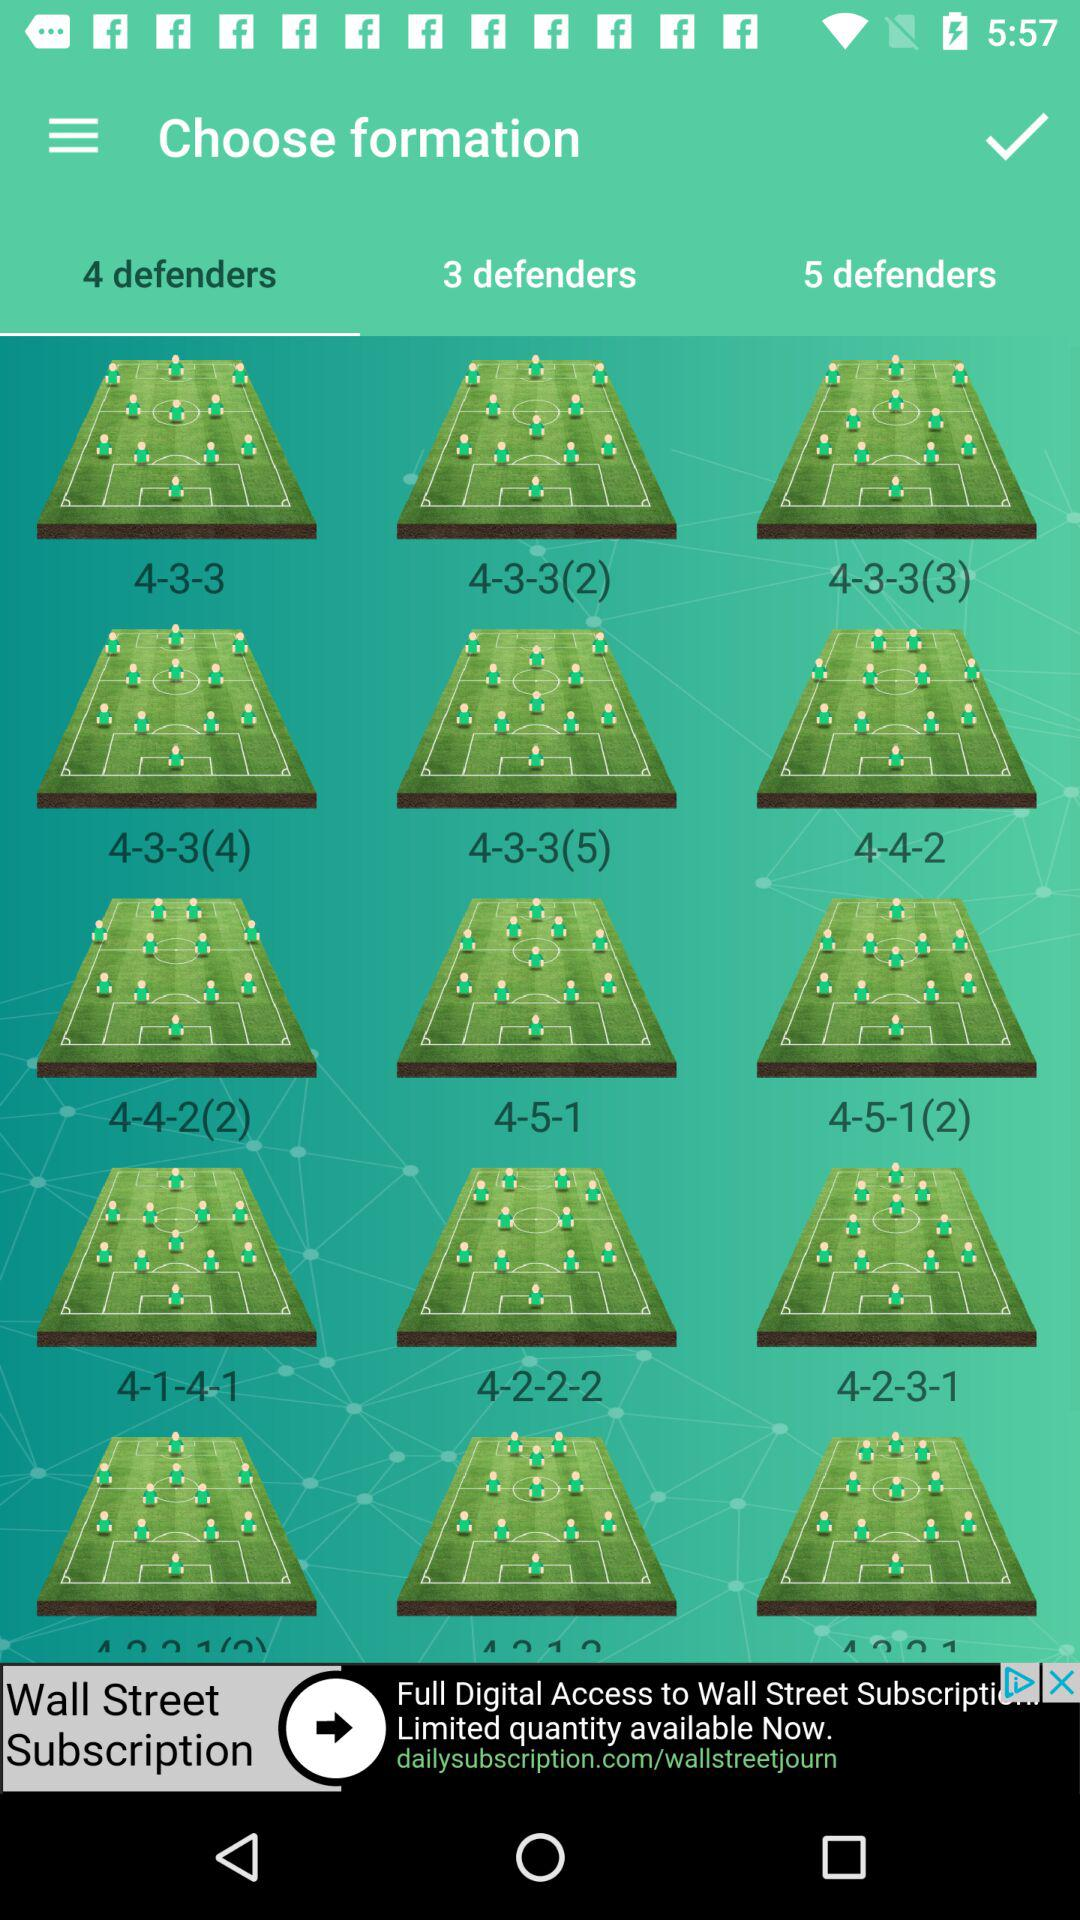Which "3 defenders" formation is selected?
When the provided information is insufficient, respond with <no answer>. <no answer> 